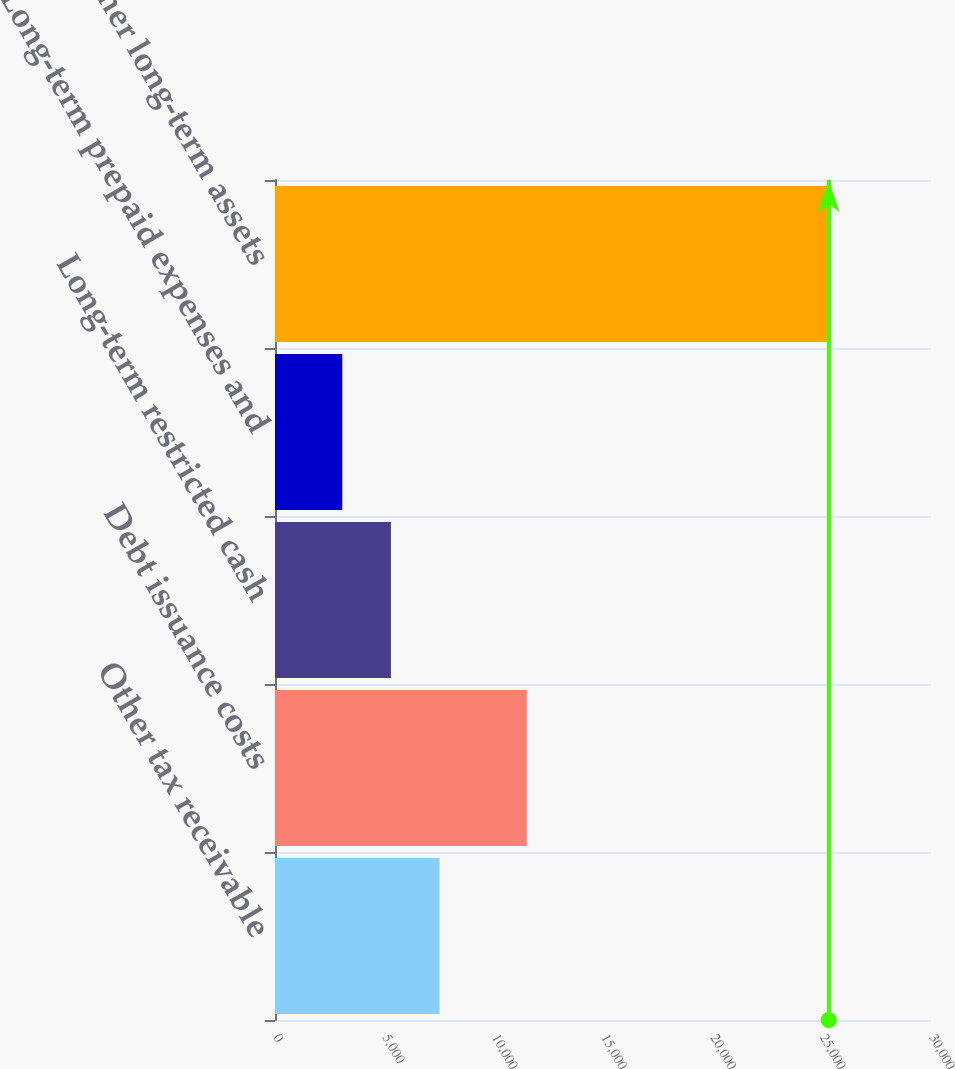<chart> <loc_0><loc_0><loc_500><loc_500><bar_chart><fcel>Other tax receivable<fcel>Debt issuance costs<fcel>Long-term restricted cash<fcel>Long-term prepaid expenses and<fcel>Total other long-term assets<nl><fcel>7525.8<fcel>11516<fcel>5300.9<fcel>3076<fcel>25325<nl></chart> 